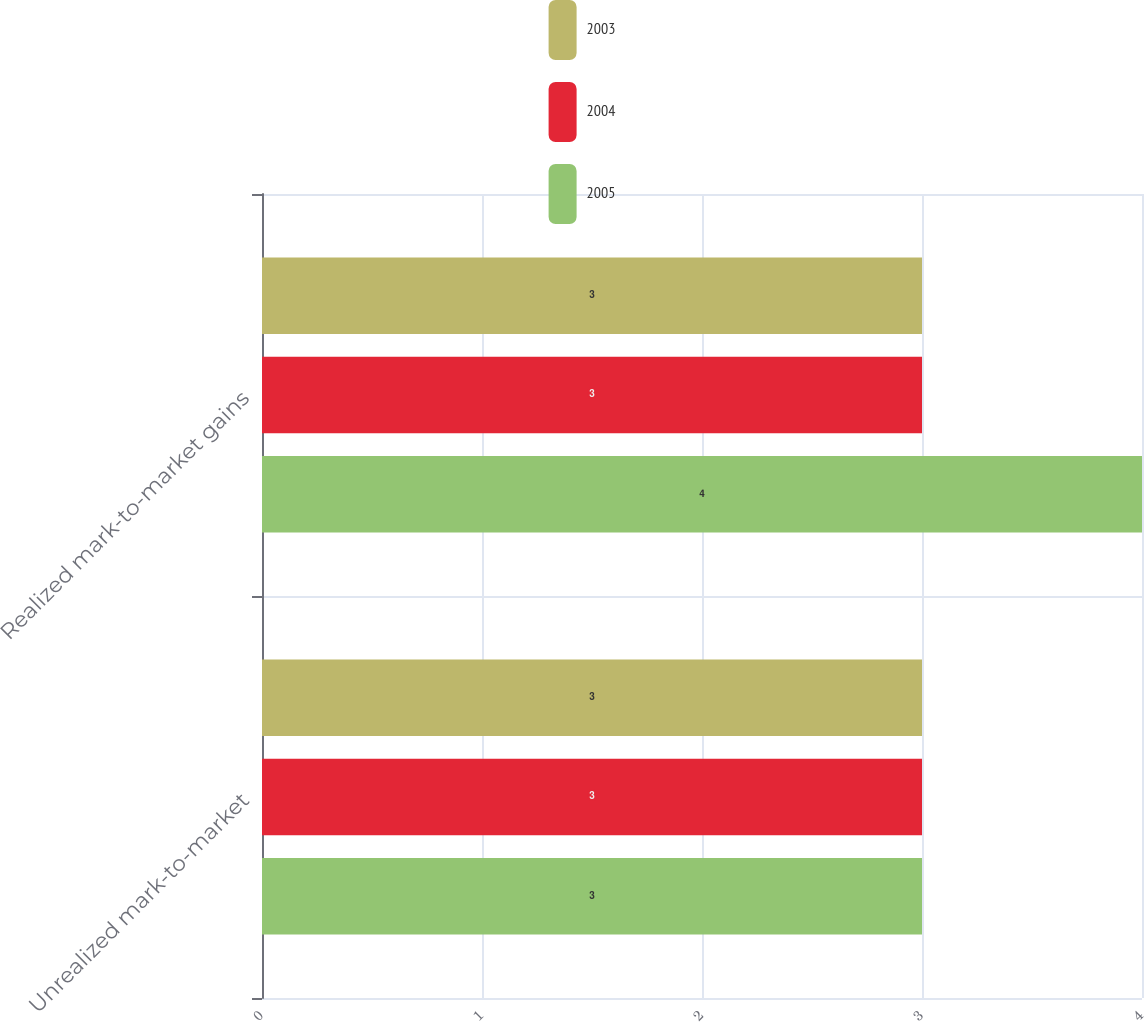Convert chart. <chart><loc_0><loc_0><loc_500><loc_500><stacked_bar_chart><ecel><fcel>Unrealized mark-to-market<fcel>Realized mark-to-market gains<nl><fcel>2003<fcel>3<fcel>3<nl><fcel>2004<fcel>3<fcel>3<nl><fcel>2005<fcel>3<fcel>4<nl></chart> 